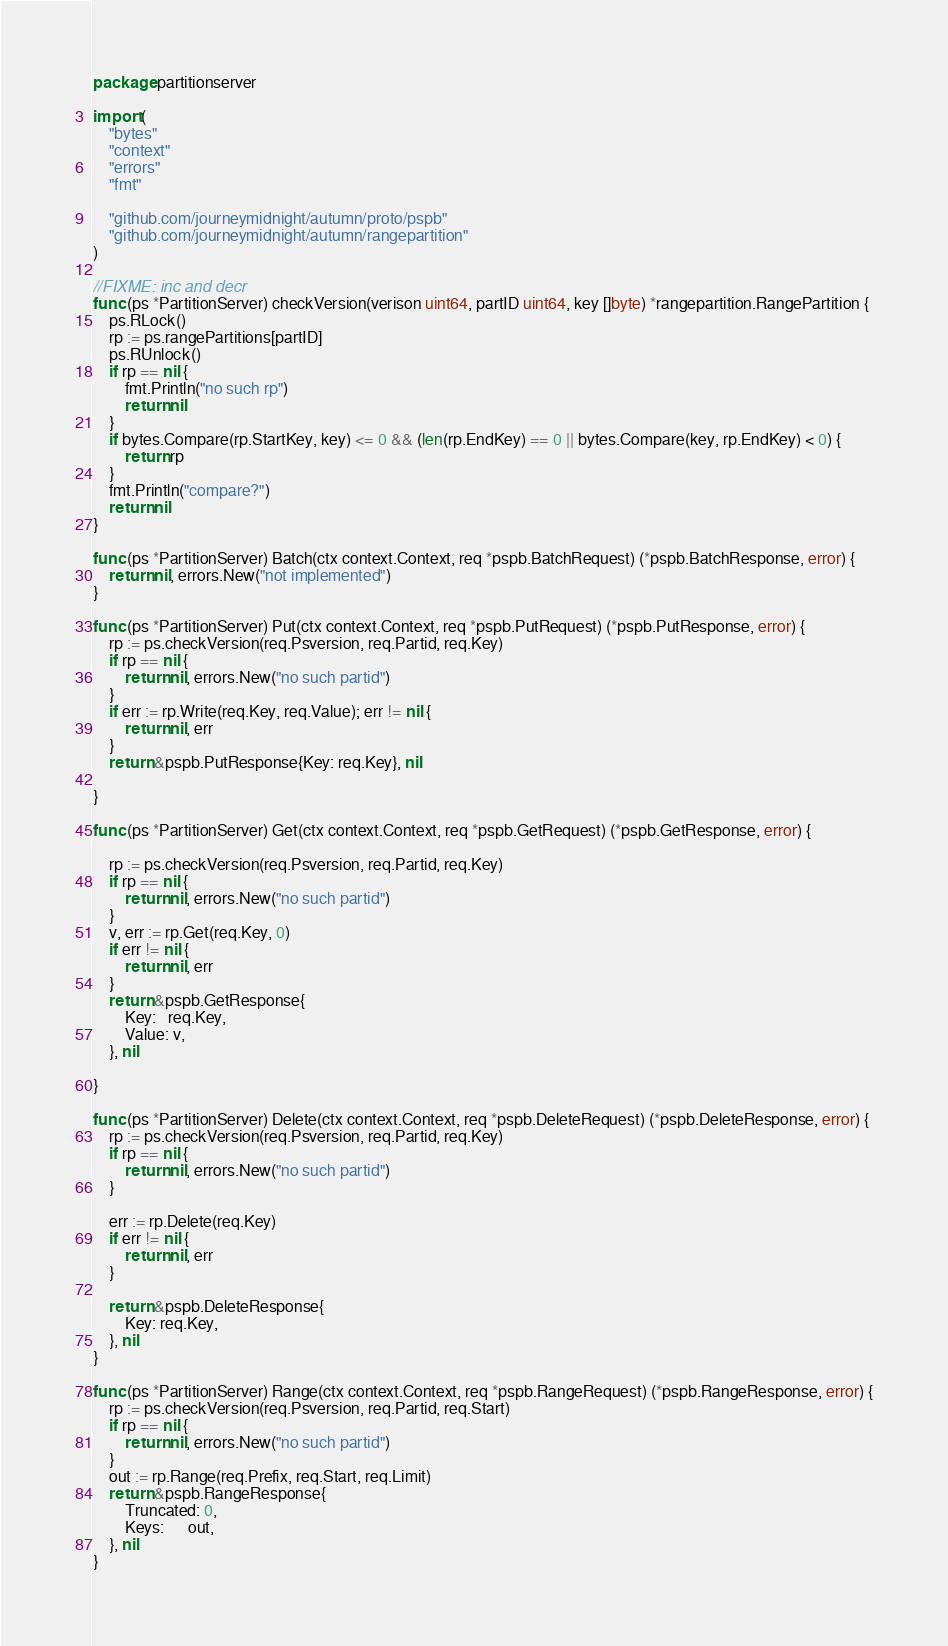<code> <loc_0><loc_0><loc_500><loc_500><_Go_>package partitionserver

import (
	"bytes"
	"context"
	"errors"
	"fmt"

	"github.com/journeymidnight/autumn/proto/pspb"
	"github.com/journeymidnight/autumn/rangepartition"
)

//FIXME: inc and decr
func (ps *PartitionServer) checkVersion(verison uint64, partID uint64, key []byte) *rangepartition.RangePartition {
	ps.RLock()
	rp := ps.rangePartitions[partID]
	ps.RUnlock()
	if rp == nil {
		fmt.Println("no such rp")
		return nil
	}
	if bytes.Compare(rp.StartKey, key) <= 0 && (len(rp.EndKey) == 0 || bytes.Compare(key, rp.EndKey) < 0) {
		return rp
	}
	fmt.Println("compare?")
	return nil
}

func (ps *PartitionServer) Batch(ctx context.Context, req *pspb.BatchRequest) (*pspb.BatchResponse, error) {
	return nil, errors.New("not implemented")
}

func (ps *PartitionServer) Put(ctx context.Context, req *pspb.PutRequest) (*pspb.PutResponse, error) {
	rp := ps.checkVersion(req.Psversion, req.Partid, req.Key)
	if rp == nil {
		return nil, errors.New("no such partid")
	}
	if err := rp.Write(req.Key, req.Value); err != nil {
		return nil, err
	}
	return &pspb.PutResponse{Key: req.Key}, nil

}

func (ps *PartitionServer) Get(ctx context.Context, req *pspb.GetRequest) (*pspb.GetResponse, error) {

	rp := ps.checkVersion(req.Psversion, req.Partid, req.Key)
	if rp == nil {
		return nil, errors.New("no such partid")
	}
	v, err := rp.Get(req.Key, 0)
	if err != nil {
		return nil, err
	}
	return &pspb.GetResponse{
		Key:   req.Key,
		Value: v,
	}, nil

}

func (ps *PartitionServer) Delete(ctx context.Context, req *pspb.DeleteRequest) (*pspb.DeleteResponse, error) {
	rp := ps.checkVersion(req.Psversion, req.Partid, req.Key)
	if rp == nil {
		return nil, errors.New("no such partid")
	}

	err := rp.Delete(req.Key)
	if err != nil {
		return nil, err
	}

	return &pspb.DeleteResponse{
		Key: req.Key,
	}, nil
}

func (ps *PartitionServer) Range(ctx context.Context, req *pspb.RangeRequest) (*pspb.RangeResponse, error) {
	rp := ps.checkVersion(req.Psversion, req.Partid, req.Start)
	if rp == nil {
		return nil, errors.New("no such partid")
	}
	out := rp.Range(req.Prefix, req.Start, req.Limit)
	return &pspb.RangeResponse{
		Truncated: 0,
		Keys:      out,
	}, nil
}
</code> 